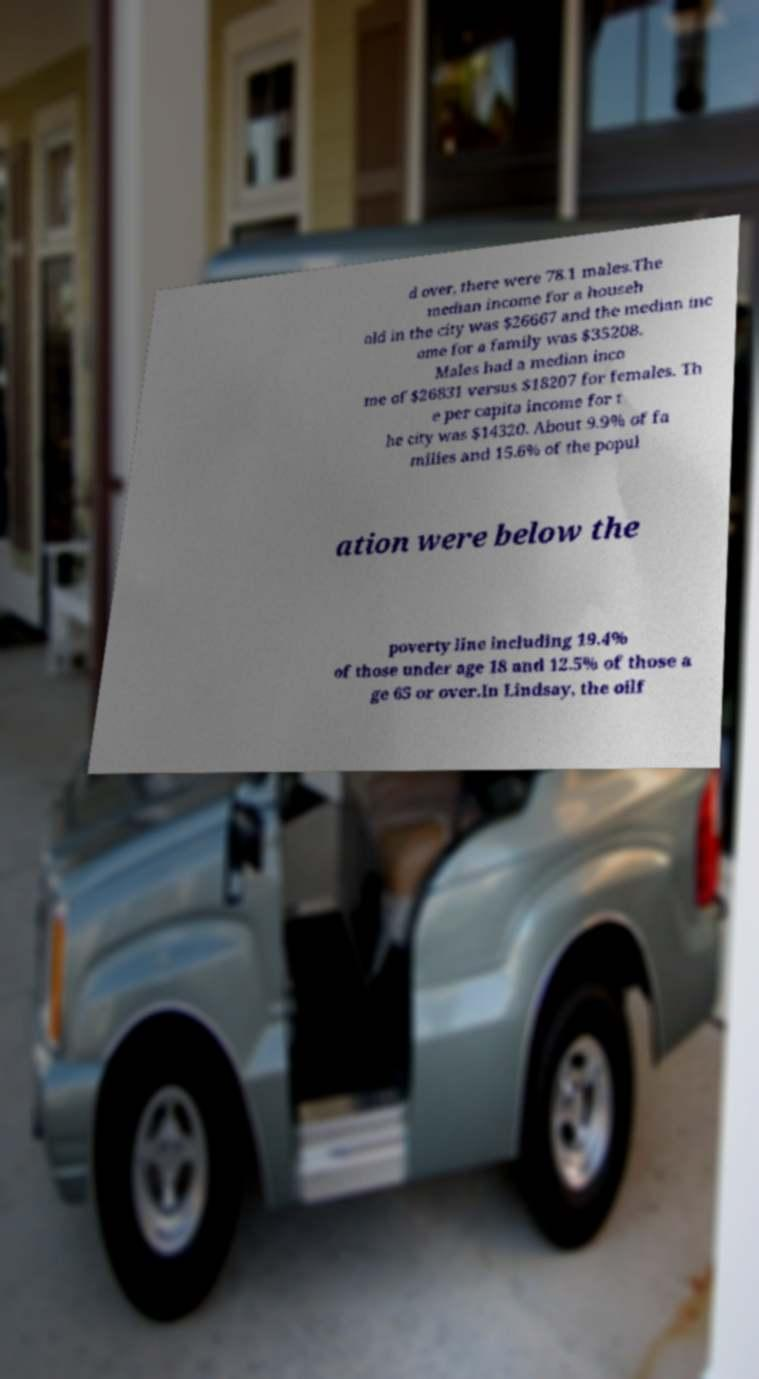I need the written content from this picture converted into text. Can you do that? d over, there were 78.1 males.The median income for a househ old in the city was $26667 and the median inc ome for a family was $35208. Males had a median inco me of $26831 versus $18207 for females. Th e per capita income for t he city was $14320. About 9.9% of fa milies and 15.6% of the popul ation were below the poverty line including 19.4% of those under age 18 and 12.5% of those a ge 65 or over.In Lindsay, the oilf 